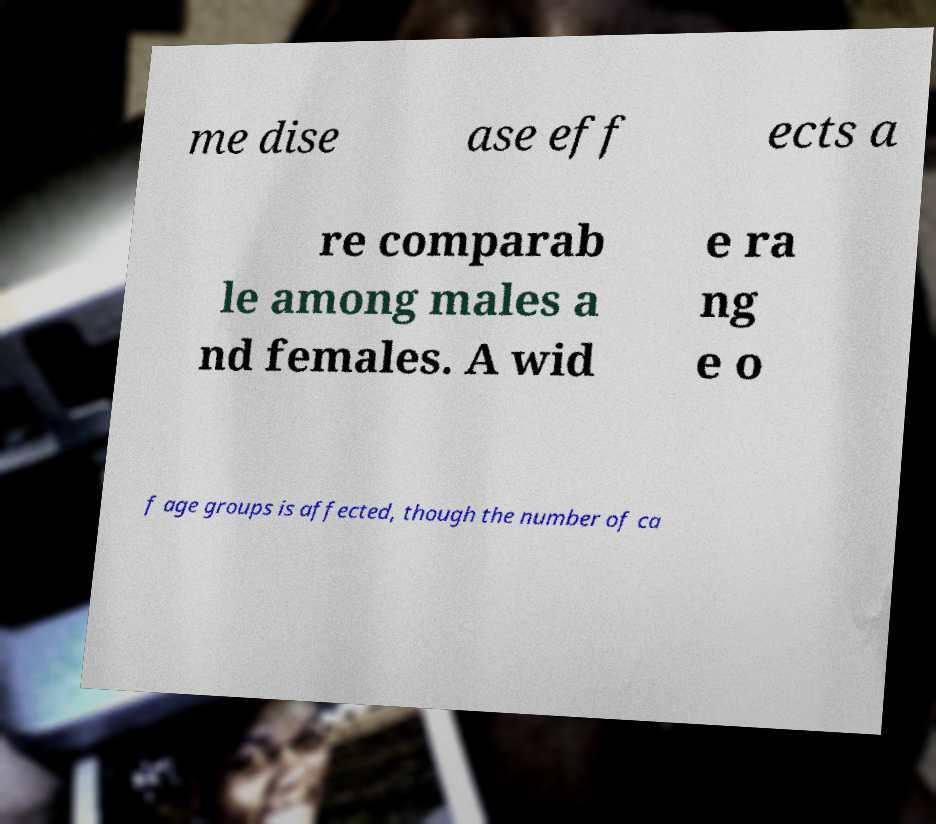Can you accurately transcribe the text from the provided image for me? me dise ase eff ects a re comparab le among males a nd females. A wid e ra ng e o f age groups is affected, though the number of ca 